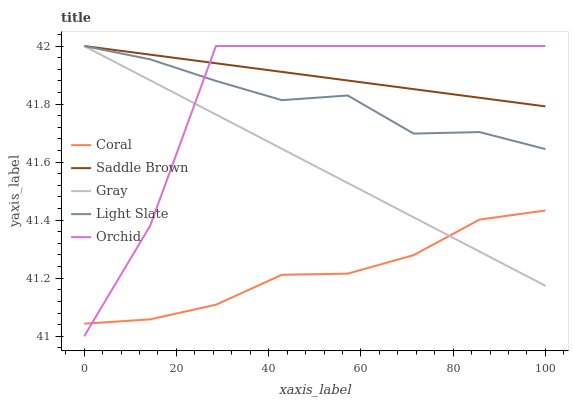Does Coral have the minimum area under the curve?
Answer yes or no. Yes. Does Saddle Brown have the maximum area under the curve?
Answer yes or no. Yes. Does Gray have the minimum area under the curve?
Answer yes or no. No. Does Gray have the maximum area under the curve?
Answer yes or no. No. Is Saddle Brown the smoothest?
Answer yes or no. Yes. Is Orchid the roughest?
Answer yes or no. Yes. Is Gray the smoothest?
Answer yes or no. No. Is Gray the roughest?
Answer yes or no. No. Does Orchid have the lowest value?
Answer yes or no. Yes. Does Gray have the lowest value?
Answer yes or no. No. Does Orchid have the highest value?
Answer yes or no. Yes. Does Coral have the highest value?
Answer yes or no. No. Is Coral less than Light Slate?
Answer yes or no. Yes. Is Light Slate greater than Coral?
Answer yes or no. Yes. Does Coral intersect Gray?
Answer yes or no. Yes. Is Coral less than Gray?
Answer yes or no. No. Is Coral greater than Gray?
Answer yes or no. No. Does Coral intersect Light Slate?
Answer yes or no. No. 